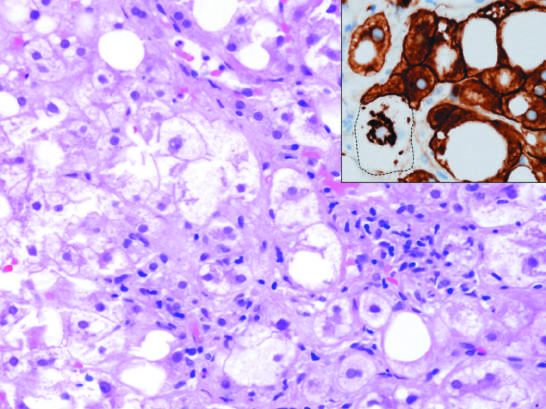does acute rheumatic mitral valvulitis stained for keratins 8 and 18 show a ballooned cell (dotted line) in which keratins have been ubiquitinylated and have collapsed into an immunoreactive mallory-denk body, leaving the cytoplasm empty?
Answer the question using a single word or phrase. No 